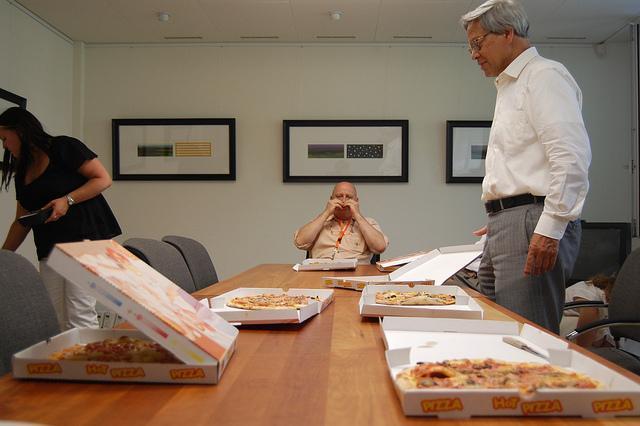How many cakes are there?
Give a very brief answer. 0. How many people are in the photo?
Give a very brief answer. 3. How many pizzas can be seen?
Give a very brief answer. 2. How many people are there?
Give a very brief answer. 3. How many chairs are in the picture?
Give a very brief answer. 3. 